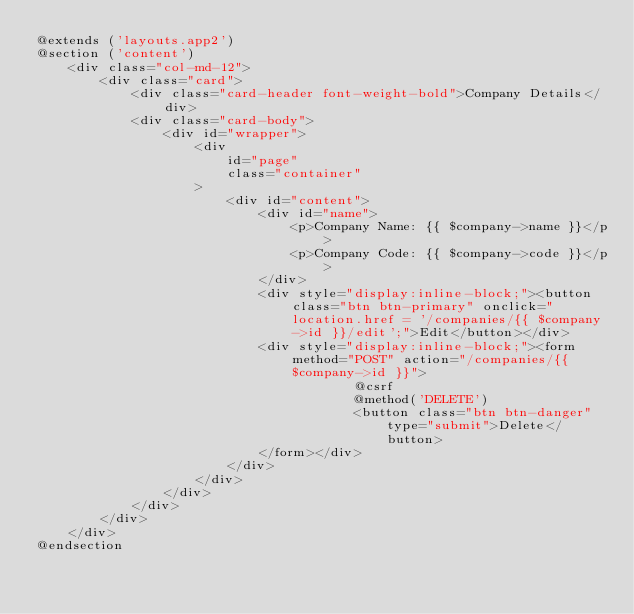Convert code to text. <code><loc_0><loc_0><loc_500><loc_500><_PHP_>@extends ('layouts.app2')
@section ('content')
    <div class="col-md-12">
        <div class="card">
            <div class="card-header font-weight-bold">Company Details</div>
            <div class="card-body">
                <div id="wrapper">
                    <div
                        id="page"
                        class="container"
                    >
                        <div id="content">
                            <div id="name">
                                <p>Company Name: {{ $company->name }}</p>
                                <p>Company Code: {{ $company->code }}</p>
                            </div>
                            <div style="display:inline-block;"><button class="btn btn-primary" onclick="location.href = '/companies/{{ $company->id }}/edit';">Edit</button></div>
                            <div style="display:inline-block;"><form method="POST" action="/companies/{{ $company->id }}">
                                        @csrf
                                        @method('DELETE')
                                        <button class="btn btn-danger" type="submit">Delete</button>
                            </form></div>
                        </div>
                    </div>
                </div>
            </div>
        </div>
    </div>
@endsection
</code> 